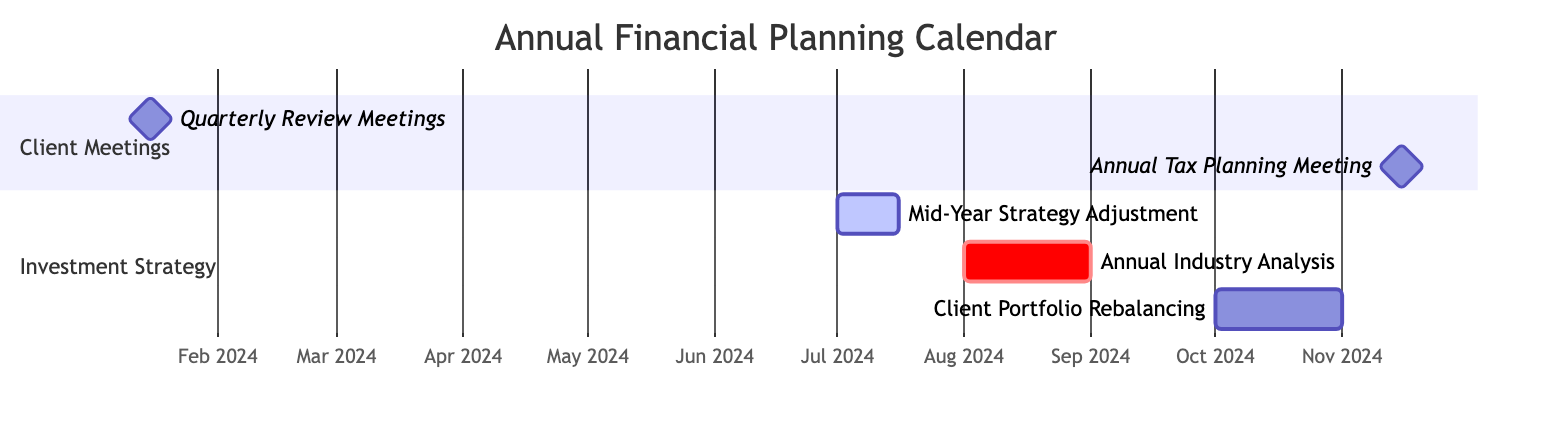What tasks are scheduled in January 2024? The diagram shows a milestone for "Quarterly Review Meetings" scheduled on January 15, 2024. Since it's the only task for that month, the answer is just that task.
Answer: Quarterly Review Meetings How many days does the "Mid-Year Strategy Adjustment" last? The task "Mid-Year Strategy Adjustment" spans from July 1, 2024, to July 15, 2024. To determine the duration, count the days: 15 days.
Answer: 15 days What is the start date of the "Annual Industry Analysis"? The diagram indicates that the "Annual Industry Analysis" task begins on August 1, 2024.
Answer: August 1, 2024 Which task follows the "Annual Tax Planning Meeting" in the timeline? After the milestone of the "Annual Tax Planning Meeting" on November 15, 2024, the next task shown is the "Client Portfolio Rebalancing," which starts on October 1, 2024. However, it overlaps in the timeline. The most immediate task is the rebalancing.
Answer: Client Portfolio Rebalancing What is the total number of tasks listed in the Gantt chart? The Gantt chart lists one task in "Client Meetings" and three tasks in "Investment Strategy" sections, making a total of five tasks combined.
Answer: 5 tasks During which month is the "Client Portfolio Rebalancing" scheduled? The "Client Portfolio Rebalancing" task is scheduled to start on October 1, 2024, and lasts until October 31, 2024, indicating it takes place in October.
Answer: October What is the relationship between "Annual Industry Analysis" and "Client Portfolio Rebalancing"? The "Annual Industry Analysis" task occurs before the "Client Portfolio Rebalancing" task, with the former ending on August 31, 2024, while the latter starts on October 1, 2024. Therefore, the relationship is sequential.
Answer: Sequential How many days in total are allocated for the investment strategy tasks? The investment strategy tasks include "Mid-Year Strategy Adjustment" (15 days), "Annual Industry Analysis" (31 days), and "Client Portfolio Rebalancing" (31 days). Adding these gives 15 + 31 + 31 = 77 days in total.
Answer: 77 days 